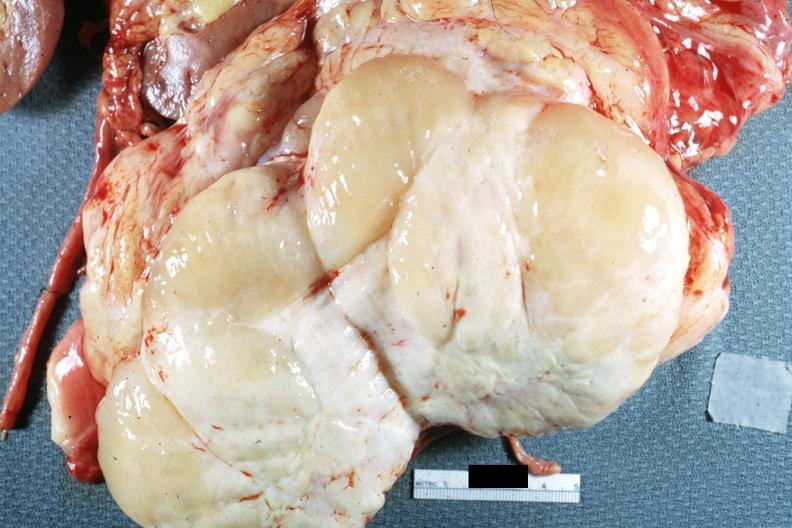what cut surface natural color yellow and white typical gross sarcoma?
Answer the question using a single word or phrase. Nodular tumor 